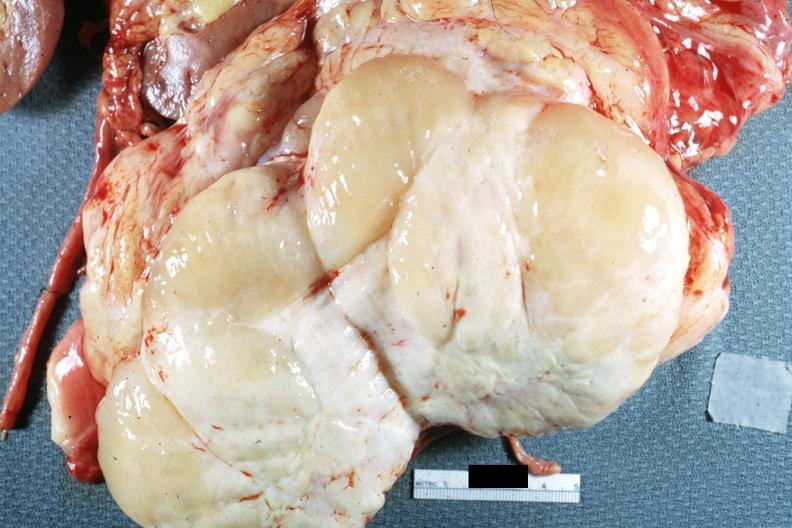what cut surface natural color yellow and white typical gross sarcoma?
Answer the question using a single word or phrase. Nodular tumor 